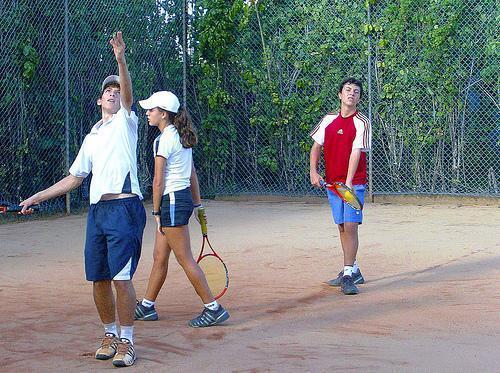How many people in the court?
Give a very brief answer. 3. 